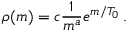Convert formula to latex. <formula><loc_0><loc_0><loc_500><loc_500>\rho ( m ) = c { \frac { 1 } { m ^ { a } } } e ^ { m / T _ { 0 } } \, .</formula> 